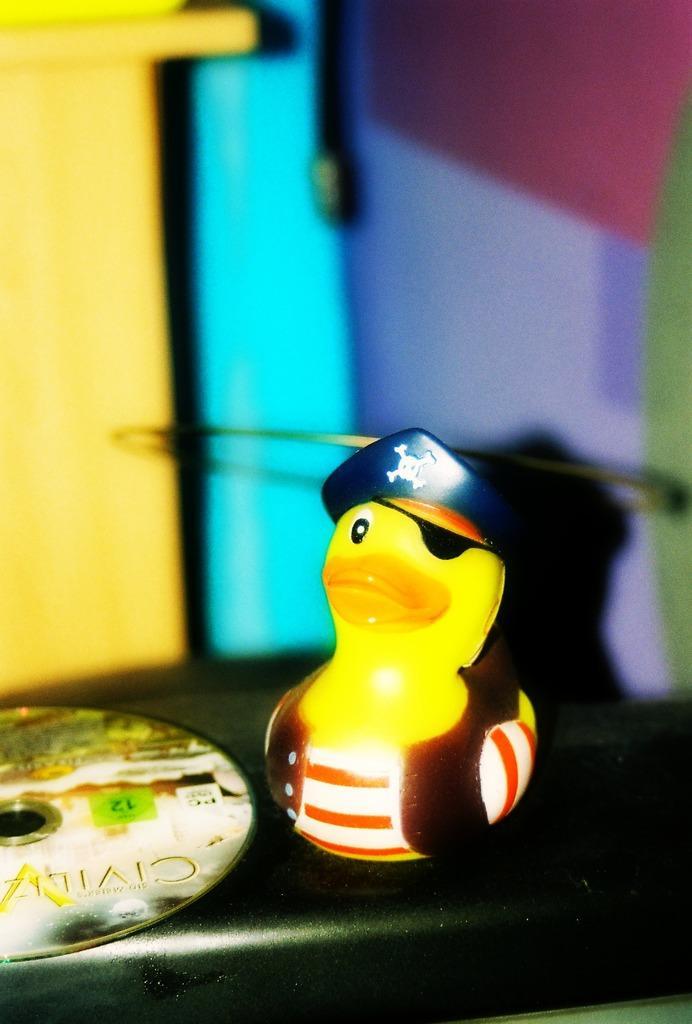Describe this image in one or two sentences. In this picture there is a small yellow color duck toy, placed on the table top. Behind there is a blur background. 